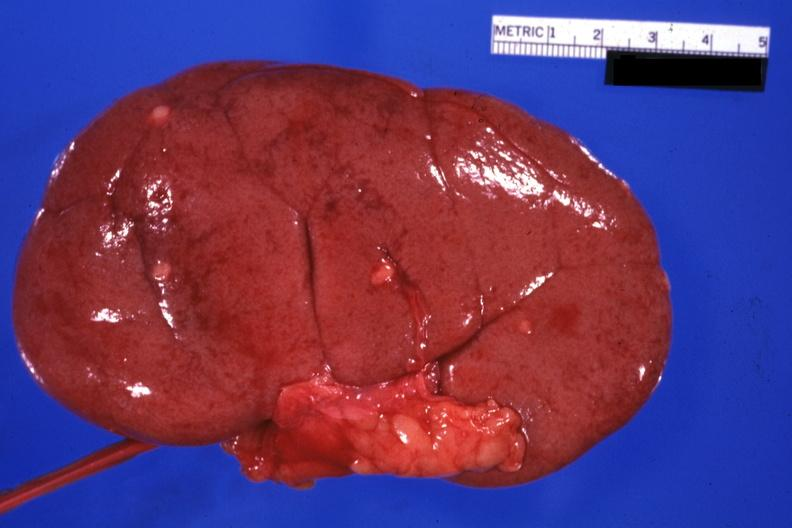s external view with capsule removed small lesions easily seen?
Answer the question using a single word or phrase. Yes 